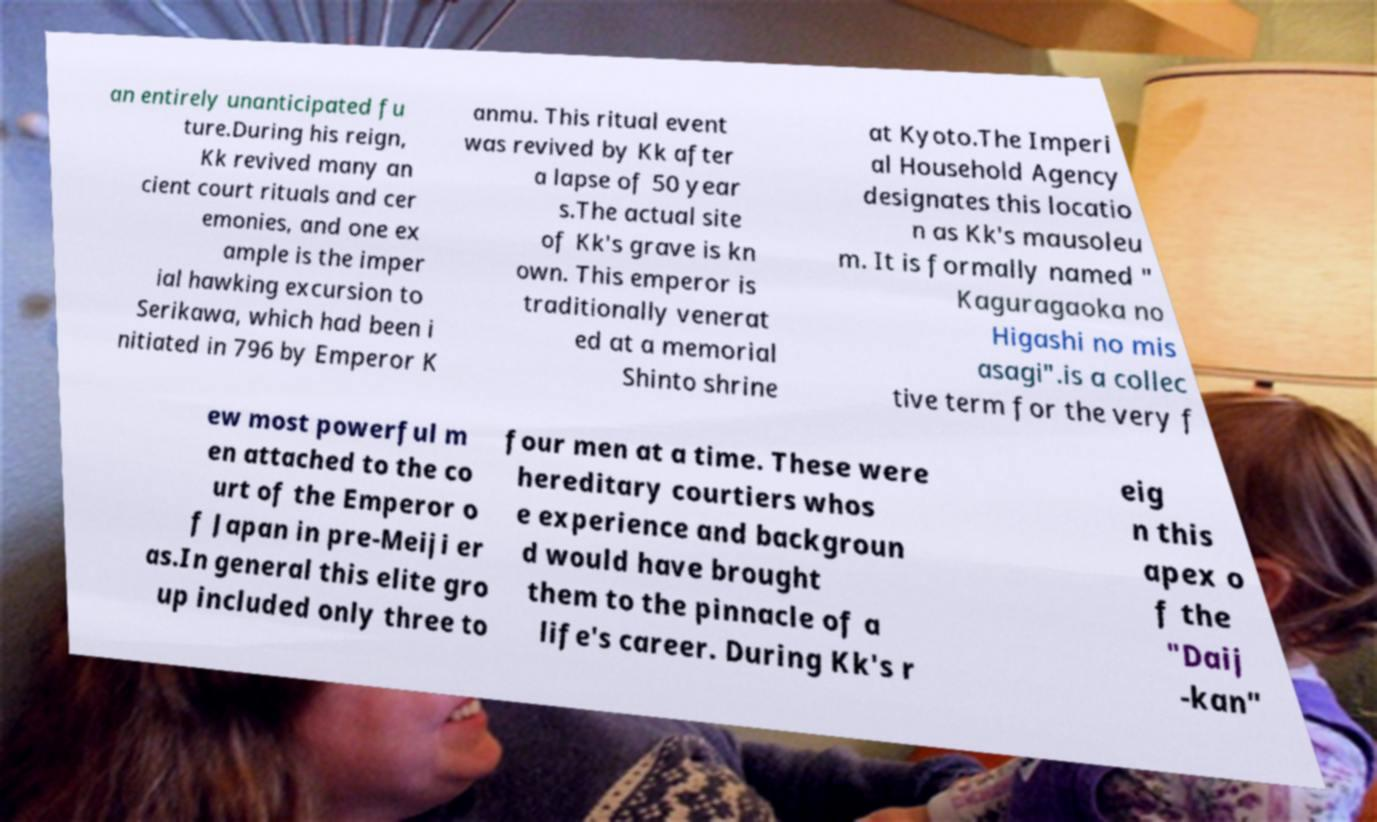For documentation purposes, I need the text within this image transcribed. Could you provide that? an entirely unanticipated fu ture.During his reign, Kk revived many an cient court rituals and cer emonies, and one ex ample is the imper ial hawking excursion to Serikawa, which had been i nitiated in 796 by Emperor K anmu. This ritual event was revived by Kk after a lapse of 50 year s.The actual site of Kk's grave is kn own. This emperor is traditionally venerat ed at a memorial Shinto shrine at Kyoto.The Imperi al Household Agency designates this locatio n as Kk's mausoleu m. It is formally named " Kaguragaoka no Higashi no mis asagi".is a collec tive term for the very f ew most powerful m en attached to the co urt of the Emperor o f Japan in pre-Meiji er as.In general this elite gro up included only three to four men at a time. These were hereditary courtiers whos e experience and backgroun d would have brought them to the pinnacle of a life's career. During Kk's r eig n this apex o f the "Daij -kan" 